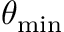<formula> <loc_0><loc_0><loc_500><loc_500>\theta _ { \min }</formula> 